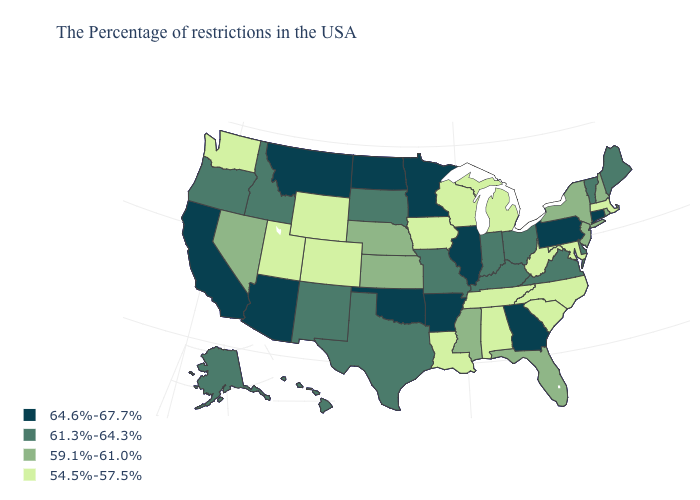Does Pennsylvania have the highest value in the USA?
Short answer required. Yes. Which states have the lowest value in the USA?
Concise answer only. Massachusetts, Maryland, North Carolina, South Carolina, West Virginia, Michigan, Alabama, Tennessee, Wisconsin, Louisiana, Iowa, Wyoming, Colorado, Utah, Washington. Does Utah have the highest value in the USA?
Be succinct. No. Which states have the highest value in the USA?
Keep it brief. Connecticut, Pennsylvania, Georgia, Illinois, Arkansas, Minnesota, Oklahoma, North Dakota, Montana, Arizona, California. Name the states that have a value in the range 61.3%-64.3%?
Be succinct. Maine, Vermont, Delaware, Virginia, Ohio, Kentucky, Indiana, Missouri, Texas, South Dakota, New Mexico, Idaho, Oregon, Alaska, Hawaii. What is the lowest value in the USA?
Short answer required. 54.5%-57.5%. What is the highest value in states that border Florida?
Keep it brief. 64.6%-67.7%. Does the first symbol in the legend represent the smallest category?
Short answer required. No. What is the value of Illinois?
Keep it brief. 64.6%-67.7%. Among the states that border New Hampshire , which have the lowest value?
Keep it brief. Massachusetts. What is the value of Ohio?
Answer briefly. 61.3%-64.3%. Which states have the lowest value in the USA?
Keep it brief. Massachusetts, Maryland, North Carolina, South Carolina, West Virginia, Michigan, Alabama, Tennessee, Wisconsin, Louisiana, Iowa, Wyoming, Colorado, Utah, Washington. Which states have the lowest value in the Northeast?
Concise answer only. Massachusetts. Name the states that have a value in the range 64.6%-67.7%?
Answer briefly. Connecticut, Pennsylvania, Georgia, Illinois, Arkansas, Minnesota, Oklahoma, North Dakota, Montana, Arizona, California. Does the map have missing data?
Quick response, please. No. 